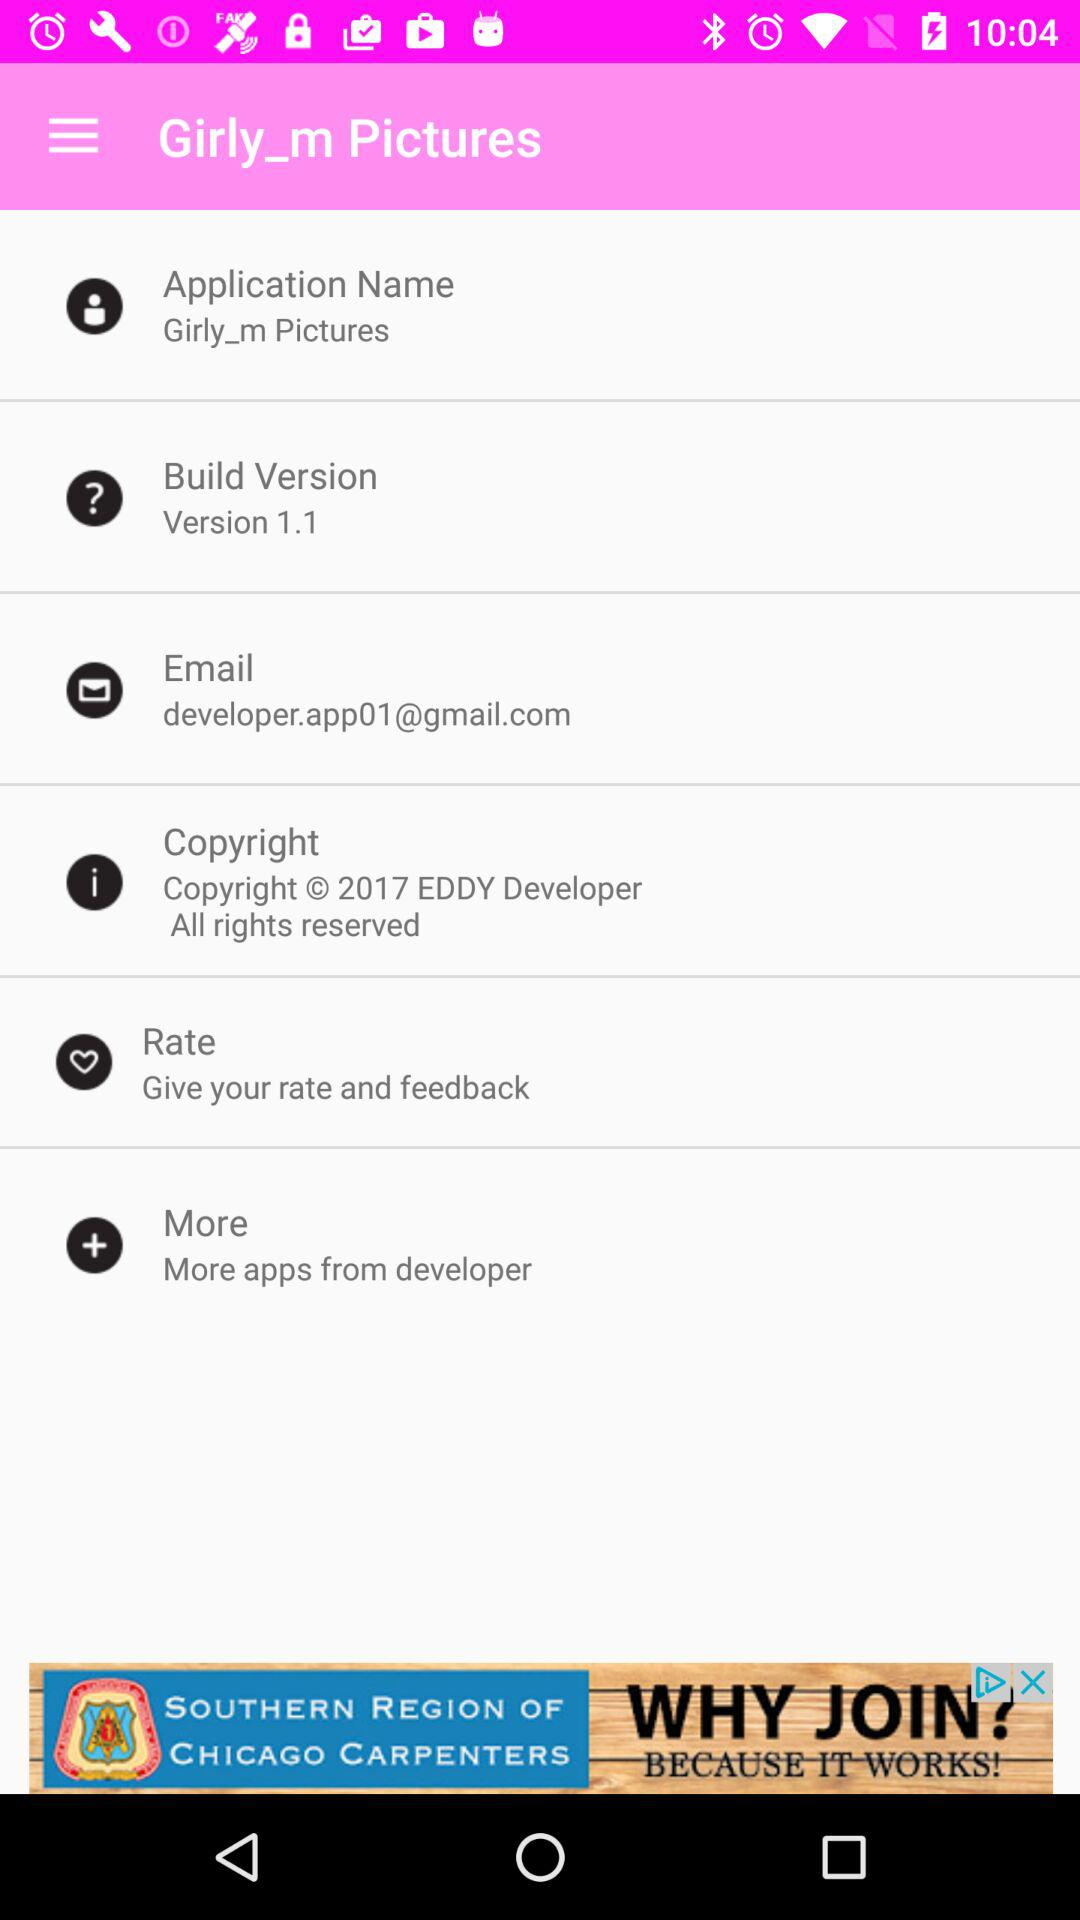What is the name of the application? The name of the application is "Girly_m Pictures". 